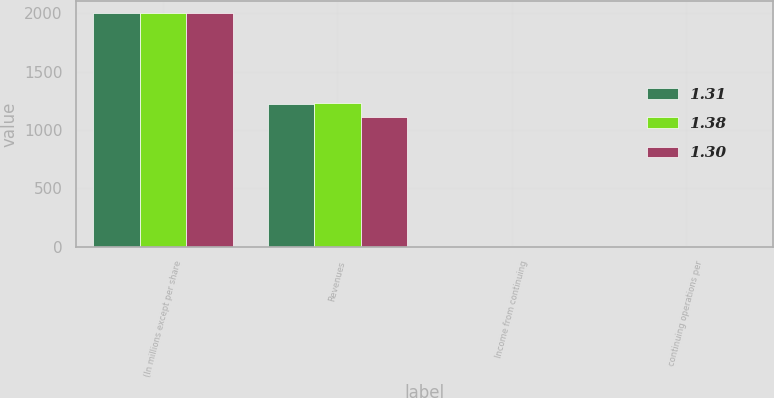Convert chart. <chart><loc_0><loc_0><loc_500><loc_500><stacked_bar_chart><ecel><fcel>(In millions except per share<fcel>Revenues<fcel>Income from continuing<fcel>continuing operations per<nl><fcel>1.31<fcel>2003<fcel>1225.4<fcel>1.33<fcel>1.31<nl><fcel>1.38<fcel>2003<fcel>1228.6<fcel>1.32<fcel>1.3<nl><fcel>1.3<fcel>2002<fcel>1109.3<fcel>1.41<fcel>1.38<nl></chart> 